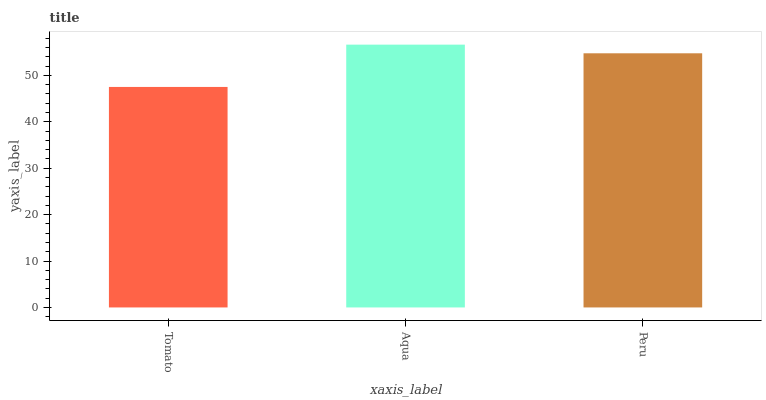Is Tomato the minimum?
Answer yes or no. Yes. Is Aqua the maximum?
Answer yes or no. Yes. Is Peru the minimum?
Answer yes or no. No. Is Peru the maximum?
Answer yes or no. No. Is Aqua greater than Peru?
Answer yes or no. Yes. Is Peru less than Aqua?
Answer yes or no. Yes. Is Peru greater than Aqua?
Answer yes or no. No. Is Aqua less than Peru?
Answer yes or no. No. Is Peru the high median?
Answer yes or no. Yes. Is Peru the low median?
Answer yes or no. Yes. Is Tomato the high median?
Answer yes or no. No. Is Aqua the low median?
Answer yes or no. No. 